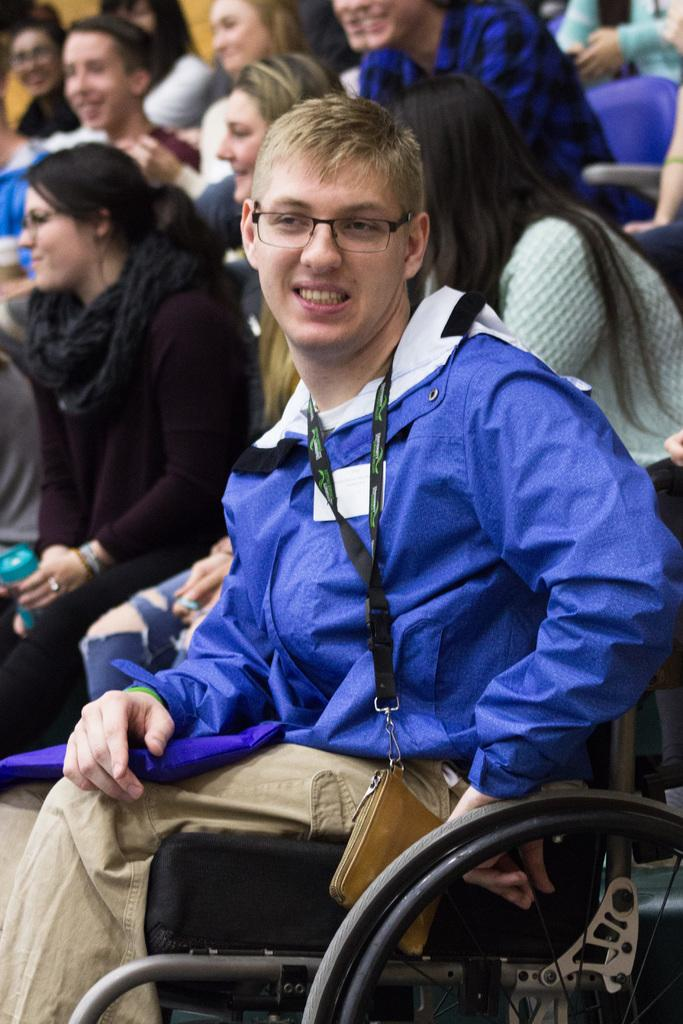What are the people in the image doing? The people in the image are sitting. Can you describe the person in the foreground of the image? There is a person sitting in a wheelchair in the foreground of the image. What is the expression of the person in the wheelchair? The person in the wheelchair is smiling. Where is the crack in the image? There is no crack present in the image. What type of lake can be seen in the background of the image? There is no lake present in the image. 